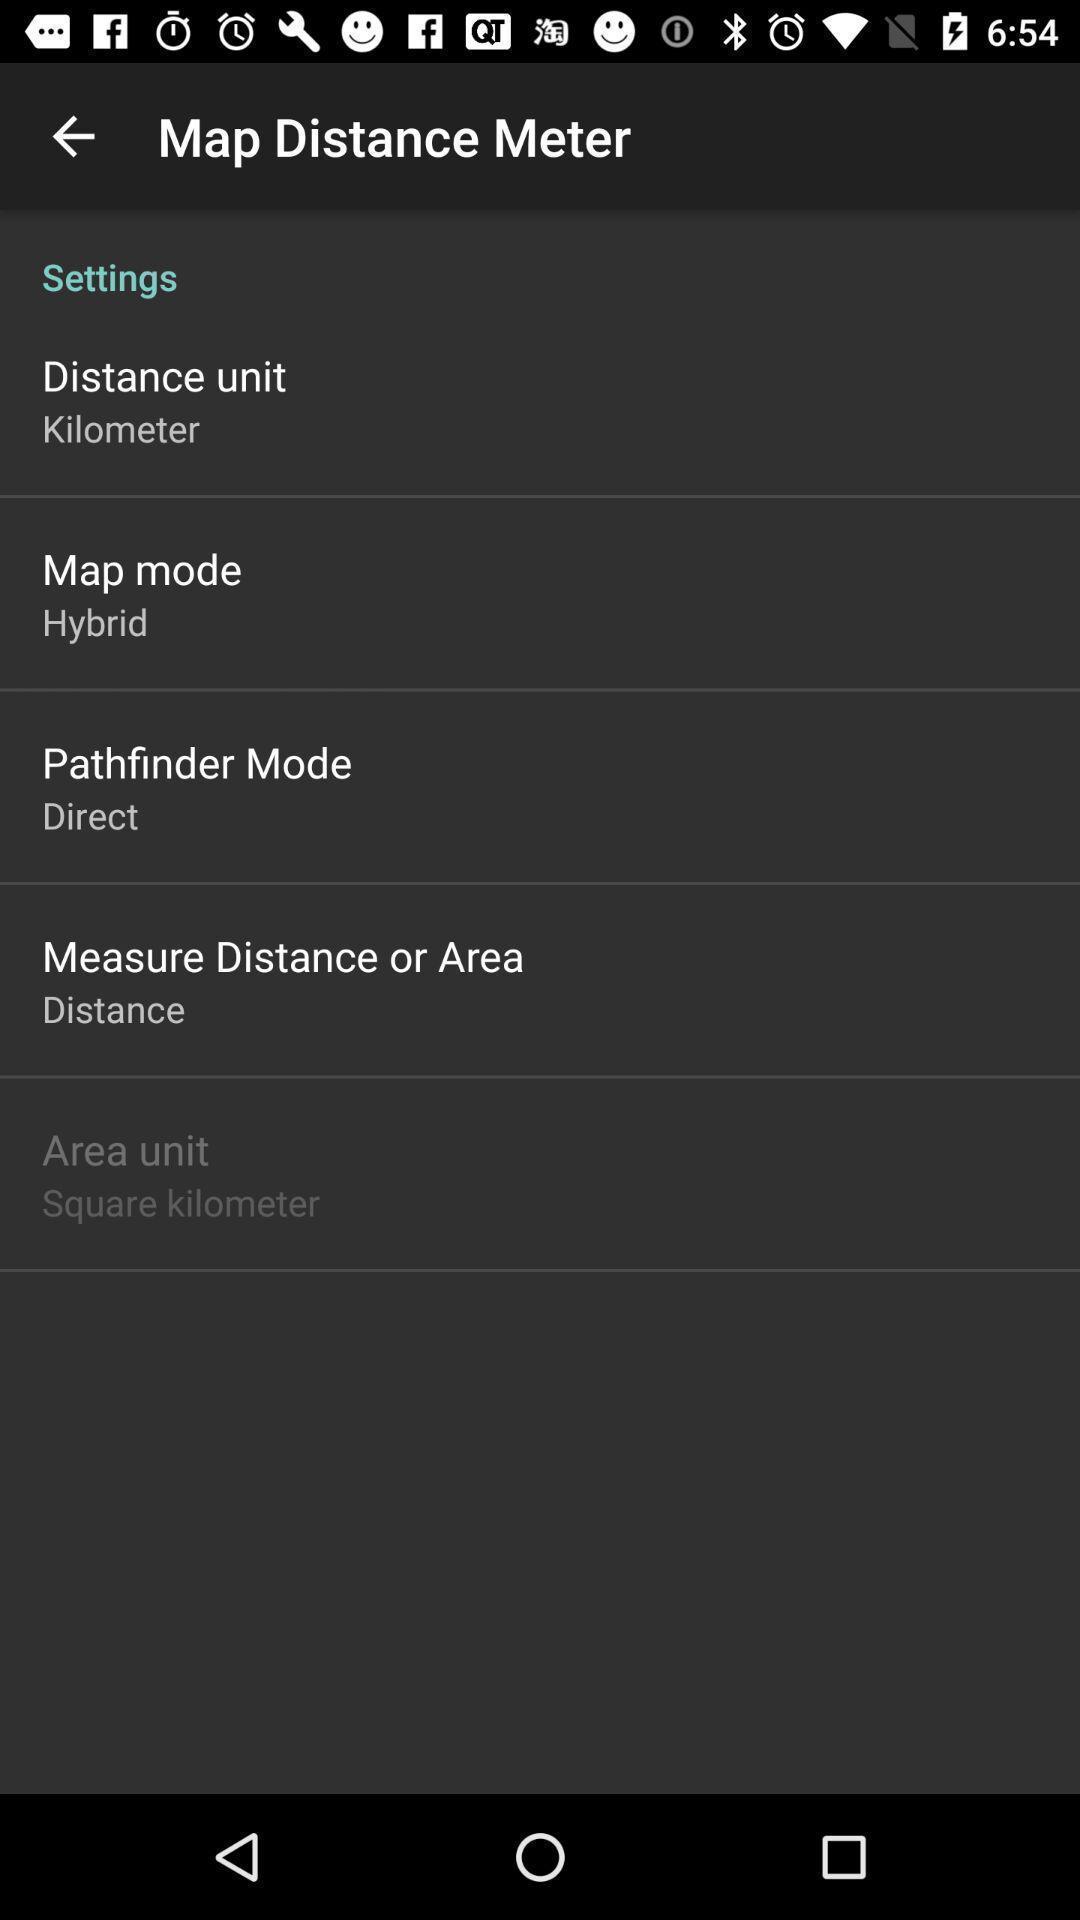What details can you identify in this image? Screen shows settings. 